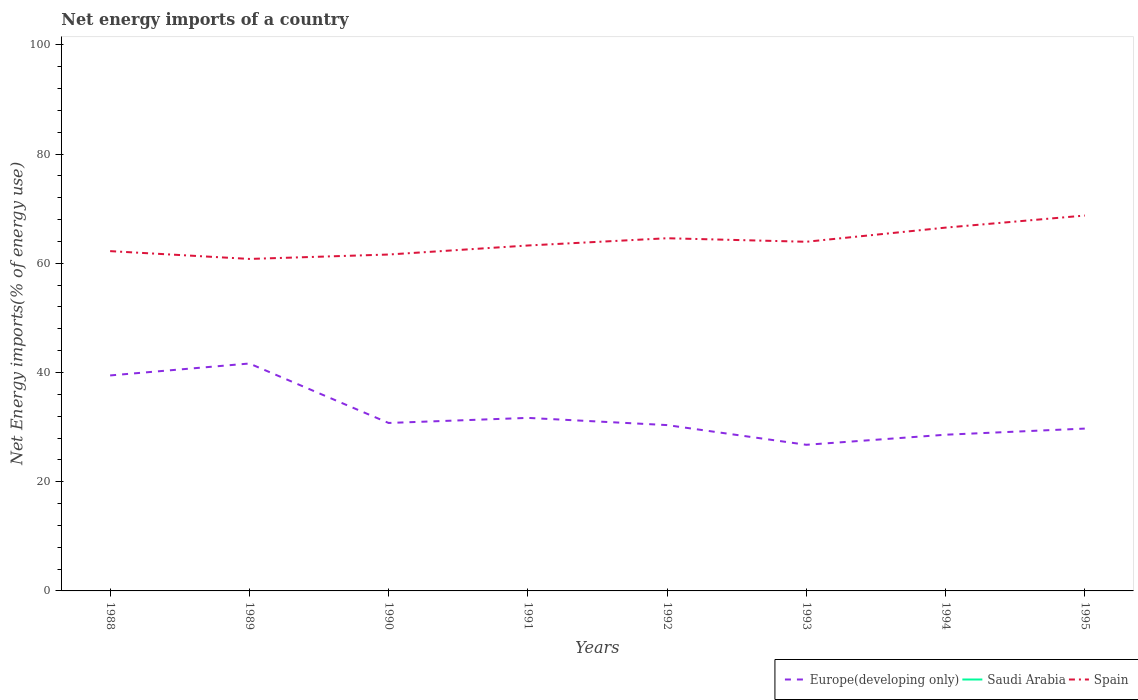How many different coloured lines are there?
Provide a short and direct response. 2. What is the total net energy imports in Spain in the graph?
Offer a terse response. -4.31. What is the difference between the highest and the second highest net energy imports in Europe(developing only)?
Provide a succinct answer. 14.88. Is the net energy imports in Saudi Arabia strictly greater than the net energy imports in Spain over the years?
Your answer should be very brief. Yes. How many years are there in the graph?
Offer a very short reply. 8. What is the difference between two consecutive major ticks on the Y-axis?
Your answer should be compact. 20. Are the values on the major ticks of Y-axis written in scientific E-notation?
Your response must be concise. No. Does the graph contain any zero values?
Make the answer very short. Yes. How are the legend labels stacked?
Make the answer very short. Horizontal. What is the title of the graph?
Your answer should be very brief. Net energy imports of a country. What is the label or title of the Y-axis?
Ensure brevity in your answer.  Net Energy imports(% of energy use). What is the Net Energy imports(% of energy use) in Europe(developing only) in 1988?
Provide a short and direct response. 39.46. What is the Net Energy imports(% of energy use) in Spain in 1988?
Your answer should be compact. 62.22. What is the Net Energy imports(% of energy use) in Europe(developing only) in 1989?
Make the answer very short. 41.64. What is the Net Energy imports(% of energy use) of Saudi Arabia in 1989?
Ensure brevity in your answer.  0. What is the Net Energy imports(% of energy use) in Spain in 1989?
Provide a succinct answer. 60.79. What is the Net Energy imports(% of energy use) in Europe(developing only) in 1990?
Your answer should be very brief. 30.75. What is the Net Energy imports(% of energy use) of Spain in 1990?
Offer a very short reply. 61.6. What is the Net Energy imports(% of energy use) in Europe(developing only) in 1991?
Offer a terse response. 31.68. What is the Net Energy imports(% of energy use) in Spain in 1991?
Ensure brevity in your answer.  63.25. What is the Net Energy imports(% of energy use) in Europe(developing only) in 1992?
Your answer should be compact. 30.36. What is the Net Energy imports(% of energy use) of Spain in 1992?
Offer a terse response. 64.58. What is the Net Energy imports(% of energy use) of Europe(developing only) in 1993?
Make the answer very short. 26.76. What is the Net Energy imports(% of energy use) of Spain in 1993?
Ensure brevity in your answer.  63.93. What is the Net Energy imports(% of energy use) in Europe(developing only) in 1994?
Offer a terse response. 28.6. What is the Net Energy imports(% of energy use) of Saudi Arabia in 1994?
Keep it short and to the point. 0. What is the Net Energy imports(% of energy use) of Spain in 1994?
Your answer should be compact. 66.52. What is the Net Energy imports(% of energy use) of Europe(developing only) in 1995?
Offer a terse response. 29.72. What is the Net Energy imports(% of energy use) of Saudi Arabia in 1995?
Your answer should be compact. 0. What is the Net Energy imports(% of energy use) in Spain in 1995?
Make the answer very short. 68.73. Across all years, what is the maximum Net Energy imports(% of energy use) in Europe(developing only)?
Your answer should be compact. 41.64. Across all years, what is the maximum Net Energy imports(% of energy use) of Spain?
Make the answer very short. 68.73. Across all years, what is the minimum Net Energy imports(% of energy use) of Europe(developing only)?
Ensure brevity in your answer.  26.76. Across all years, what is the minimum Net Energy imports(% of energy use) of Spain?
Provide a short and direct response. 60.79. What is the total Net Energy imports(% of energy use) of Europe(developing only) in the graph?
Ensure brevity in your answer.  258.98. What is the total Net Energy imports(% of energy use) in Spain in the graph?
Offer a very short reply. 511.62. What is the difference between the Net Energy imports(% of energy use) in Europe(developing only) in 1988 and that in 1989?
Your response must be concise. -2.19. What is the difference between the Net Energy imports(% of energy use) in Spain in 1988 and that in 1989?
Your answer should be very brief. 1.43. What is the difference between the Net Energy imports(% of energy use) of Europe(developing only) in 1988 and that in 1990?
Your answer should be very brief. 8.7. What is the difference between the Net Energy imports(% of energy use) in Spain in 1988 and that in 1990?
Offer a terse response. 0.62. What is the difference between the Net Energy imports(% of energy use) of Europe(developing only) in 1988 and that in 1991?
Offer a very short reply. 7.77. What is the difference between the Net Energy imports(% of energy use) of Spain in 1988 and that in 1991?
Offer a terse response. -1.03. What is the difference between the Net Energy imports(% of energy use) of Europe(developing only) in 1988 and that in 1992?
Provide a short and direct response. 9.09. What is the difference between the Net Energy imports(% of energy use) of Spain in 1988 and that in 1992?
Offer a very short reply. -2.36. What is the difference between the Net Energy imports(% of energy use) of Europe(developing only) in 1988 and that in 1993?
Your answer should be compact. 12.7. What is the difference between the Net Energy imports(% of energy use) in Spain in 1988 and that in 1993?
Give a very brief answer. -1.71. What is the difference between the Net Energy imports(% of energy use) of Europe(developing only) in 1988 and that in 1994?
Offer a terse response. 10.85. What is the difference between the Net Energy imports(% of energy use) of Spain in 1988 and that in 1994?
Ensure brevity in your answer.  -4.31. What is the difference between the Net Energy imports(% of energy use) of Europe(developing only) in 1988 and that in 1995?
Your answer should be compact. 9.73. What is the difference between the Net Energy imports(% of energy use) in Spain in 1988 and that in 1995?
Offer a terse response. -6.52. What is the difference between the Net Energy imports(% of energy use) of Europe(developing only) in 1989 and that in 1990?
Offer a very short reply. 10.89. What is the difference between the Net Energy imports(% of energy use) of Spain in 1989 and that in 1990?
Keep it short and to the point. -0.81. What is the difference between the Net Energy imports(% of energy use) of Europe(developing only) in 1989 and that in 1991?
Offer a very short reply. 9.96. What is the difference between the Net Energy imports(% of energy use) in Spain in 1989 and that in 1991?
Provide a succinct answer. -2.46. What is the difference between the Net Energy imports(% of energy use) in Europe(developing only) in 1989 and that in 1992?
Your answer should be very brief. 11.28. What is the difference between the Net Energy imports(% of energy use) in Spain in 1989 and that in 1992?
Your answer should be compact. -3.79. What is the difference between the Net Energy imports(% of energy use) of Europe(developing only) in 1989 and that in 1993?
Provide a succinct answer. 14.88. What is the difference between the Net Energy imports(% of energy use) of Spain in 1989 and that in 1993?
Keep it short and to the point. -3.14. What is the difference between the Net Energy imports(% of energy use) of Europe(developing only) in 1989 and that in 1994?
Keep it short and to the point. 13.04. What is the difference between the Net Energy imports(% of energy use) in Spain in 1989 and that in 1994?
Give a very brief answer. -5.74. What is the difference between the Net Energy imports(% of energy use) in Europe(developing only) in 1989 and that in 1995?
Provide a short and direct response. 11.92. What is the difference between the Net Energy imports(% of energy use) in Spain in 1989 and that in 1995?
Provide a short and direct response. -7.95. What is the difference between the Net Energy imports(% of energy use) of Europe(developing only) in 1990 and that in 1991?
Provide a succinct answer. -0.93. What is the difference between the Net Energy imports(% of energy use) in Spain in 1990 and that in 1991?
Your response must be concise. -1.65. What is the difference between the Net Energy imports(% of energy use) of Europe(developing only) in 1990 and that in 1992?
Make the answer very short. 0.39. What is the difference between the Net Energy imports(% of energy use) of Spain in 1990 and that in 1992?
Offer a terse response. -2.98. What is the difference between the Net Energy imports(% of energy use) in Europe(developing only) in 1990 and that in 1993?
Provide a succinct answer. 4. What is the difference between the Net Energy imports(% of energy use) in Spain in 1990 and that in 1993?
Give a very brief answer. -2.33. What is the difference between the Net Energy imports(% of energy use) of Europe(developing only) in 1990 and that in 1994?
Your response must be concise. 2.15. What is the difference between the Net Energy imports(% of energy use) of Spain in 1990 and that in 1994?
Make the answer very short. -4.93. What is the difference between the Net Energy imports(% of energy use) in Europe(developing only) in 1990 and that in 1995?
Offer a terse response. 1.03. What is the difference between the Net Energy imports(% of energy use) in Spain in 1990 and that in 1995?
Make the answer very short. -7.14. What is the difference between the Net Energy imports(% of energy use) of Europe(developing only) in 1991 and that in 1992?
Keep it short and to the point. 1.32. What is the difference between the Net Energy imports(% of energy use) in Spain in 1991 and that in 1992?
Keep it short and to the point. -1.33. What is the difference between the Net Energy imports(% of energy use) of Europe(developing only) in 1991 and that in 1993?
Your answer should be very brief. 4.93. What is the difference between the Net Energy imports(% of energy use) in Spain in 1991 and that in 1993?
Your answer should be compact. -0.68. What is the difference between the Net Energy imports(% of energy use) of Europe(developing only) in 1991 and that in 1994?
Provide a short and direct response. 3.08. What is the difference between the Net Energy imports(% of energy use) in Spain in 1991 and that in 1994?
Offer a very short reply. -3.27. What is the difference between the Net Energy imports(% of energy use) of Europe(developing only) in 1991 and that in 1995?
Make the answer very short. 1.96. What is the difference between the Net Energy imports(% of energy use) of Spain in 1991 and that in 1995?
Your answer should be very brief. -5.48. What is the difference between the Net Energy imports(% of energy use) in Europe(developing only) in 1992 and that in 1993?
Give a very brief answer. 3.61. What is the difference between the Net Energy imports(% of energy use) in Spain in 1992 and that in 1993?
Provide a succinct answer. 0.65. What is the difference between the Net Energy imports(% of energy use) of Europe(developing only) in 1992 and that in 1994?
Your answer should be compact. 1.76. What is the difference between the Net Energy imports(% of energy use) of Spain in 1992 and that in 1994?
Your response must be concise. -1.95. What is the difference between the Net Energy imports(% of energy use) in Europe(developing only) in 1992 and that in 1995?
Your response must be concise. 0.64. What is the difference between the Net Energy imports(% of energy use) of Spain in 1992 and that in 1995?
Ensure brevity in your answer.  -4.16. What is the difference between the Net Energy imports(% of energy use) of Europe(developing only) in 1993 and that in 1994?
Offer a terse response. -1.84. What is the difference between the Net Energy imports(% of energy use) of Spain in 1993 and that in 1994?
Provide a succinct answer. -2.59. What is the difference between the Net Energy imports(% of energy use) in Europe(developing only) in 1993 and that in 1995?
Give a very brief answer. -2.97. What is the difference between the Net Energy imports(% of energy use) of Spain in 1993 and that in 1995?
Provide a succinct answer. -4.8. What is the difference between the Net Energy imports(% of energy use) of Europe(developing only) in 1994 and that in 1995?
Keep it short and to the point. -1.12. What is the difference between the Net Energy imports(% of energy use) in Spain in 1994 and that in 1995?
Your answer should be compact. -2.21. What is the difference between the Net Energy imports(% of energy use) of Europe(developing only) in 1988 and the Net Energy imports(% of energy use) of Spain in 1989?
Make the answer very short. -21.33. What is the difference between the Net Energy imports(% of energy use) of Europe(developing only) in 1988 and the Net Energy imports(% of energy use) of Spain in 1990?
Make the answer very short. -22.14. What is the difference between the Net Energy imports(% of energy use) in Europe(developing only) in 1988 and the Net Energy imports(% of energy use) in Spain in 1991?
Your response must be concise. -23.79. What is the difference between the Net Energy imports(% of energy use) of Europe(developing only) in 1988 and the Net Energy imports(% of energy use) of Spain in 1992?
Make the answer very short. -25.12. What is the difference between the Net Energy imports(% of energy use) of Europe(developing only) in 1988 and the Net Energy imports(% of energy use) of Spain in 1993?
Your answer should be compact. -24.48. What is the difference between the Net Energy imports(% of energy use) in Europe(developing only) in 1988 and the Net Energy imports(% of energy use) in Spain in 1994?
Give a very brief answer. -27.07. What is the difference between the Net Energy imports(% of energy use) of Europe(developing only) in 1988 and the Net Energy imports(% of energy use) of Spain in 1995?
Provide a short and direct response. -29.28. What is the difference between the Net Energy imports(% of energy use) of Europe(developing only) in 1989 and the Net Energy imports(% of energy use) of Spain in 1990?
Ensure brevity in your answer.  -19.95. What is the difference between the Net Energy imports(% of energy use) of Europe(developing only) in 1989 and the Net Energy imports(% of energy use) of Spain in 1991?
Give a very brief answer. -21.61. What is the difference between the Net Energy imports(% of energy use) in Europe(developing only) in 1989 and the Net Energy imports(% of energy use) in Spain in 1992?
Your response must be concise. -22.94. What is the difference between the Net Energy imports(% of energy use) in Europe(developing only) in 1989 and the Net Energy imports(% of energy use) in Spain in 1993?
Provide a succinct answer. -22.29. What is the difference between the Net Energy imports(% of energy use) in Europe(developing only) in 1989 and the Net Energy imports(% of energy use) in Spain in 1994?
Your response must be concise. -24.88. What is the difference between the Net Energy imports(% of energy use) of Europe(developing only) in 1989 and the Net Energy imports(% of energy use) of Spain in 1995?
Ensure brevity in your answer.  -27.09. What is the difference between the Net Energy imports(% of energy use) of Europe(developing only) in 1990 and the Net Energy imports(% of energy use) of Spain in 1991?
Keep it short and to the point. -32.49. What is the difference between the Net Energy imports(% of energy use) in Europe(developing only) in 1990 and the Net Energy imports(% of energy use) in Spain in 1992?
Keep it short and to the point. -33.82. What is the difference between the Net Energy imports(% of energy use) of Europe(developing only) in 1990 and the Net Energy imports(% of energy use) of Spain in 1993?
Keep it short and to the point. -33.18. What is the difference between the Net Energy imports(% of energy use) of Europe(developing only) in 1990 and the Net Energy imports(% of energy use) of Spain in 1994?
Your answer should be compact. -35.77. What is the difference between the Net Energy imports(% of energy use) in Europe(developing only) in 1990 and the Net Energy imports(% of energy use) in Spain in 1995?
Offer a very short reply. -37.98. What is the difference between the Net Energy imports(% of energy use) in Europe(developing only) in 1991 and the Net Energy imports(% of energy use) in Spain in 1992?
Give a very brief answer. -32.89. What is the difference between the Net Energy imports(% of energy use) in Europe(developing only) in 1991 and the Net Energy imports(% of energy use) in Spain in 1993?
Provide a short and direct response. -32.25. What is the difference between the Net Energy imports(% of energy use) of Europe(developing only) in 1991 and the Net Energy imports(% of energy use) of Spain in 1994?
Make the answer very short. -34.84. What is the difference between the Net Energy imports(% of energy use) in Europe(developing only) in 1991 and the Net Energy imports(% of energy use) in Spain in 1995?
Make the answer very short. -37.05. What is the difference between the Net Energy imports(% of energy use) of Europe(developing only) in 1992 and the Net Energy imports(% of energy use) of Spain in 1993?
Provide a short and direct response. -33.57. What is the difference between the Net Energy imports(% of energy use) of Europe(developing only) in 1992 and the Net Energy imports(% of energy use) of Spain in 1994?
Keep it short and to the point. -36.16. What is the difference between the Net Energy imports(% of energy use) in Europe(developing only) in 1992 and the Net Energy imports(% of energy use) in Spain in 1995?
Offer a very short reply. -38.37. What is the difference between the Net Energy imports(% of energy use) of Europe(developing only) in 1993 and the Net Energy imports(% of energy use) of Spain in 1994?
Offer a terse response. -39.77. What is the difference between the Net Energy imports(% of energy use) of Europe(developing only) in 1993 and the Net Energy imports(% of energy use) of Spain in 1995?
Give a very brief answer. -41.98. What is the difference between the Net Energy imports(% of energy use) of Europe(developing only) in 1994 and the Net Energy imports(% of energy use) of Spain in 1995?
Provide a succinct answer. -40.13. What is the average Net Energy imports(% of energy use) in Europe(developing only) per year?
Offer a terse response. 32.37. What is the average Net Energy imports(% of energy use) of Spain per year?
Ensure brevity in your answer.  63.95. In the year 1988, what is the difference between the Net Energy imports(% of energy use) of Europe(developing only) and Net Energy imports(% of energy use) of Spain?
Provide a succinct answer. -22.76. In the year 1989, what is the difference between the Net Energy imports(% of energy use) in Europe(developing only) and Net Energy imports(% of energy use) in Spain?
Offer a terse response. -19.15. In the year 1990, what is the difference between the Net Energy imports(% of energy use) of Europe(developing only) and Net Energy imports(% of energy use) of Spain?
Ensure brevity in your answer.  -30.84. In the year 1991, what is the difference between the Net Energy imports(% of energy use) of Europe(developing only) and Net Energy imports(% of energy use) of Spain?
Ensure brevity in your answer.  -31.57. In the year 1992, what is the difference between the Net Energy imports(% of energy use) of Europe(developing only) and Net Energy imports(% of energy use) of Spain?
Your answer should be very brief. -34.21. In the year 1993, what is the difference between the Net Energy imports(% of energy use) of Europe(developing only) and Net Energy imports(% of energy use) of Spain?
Provide a short and direct response. -37.17. In the year 1994, what is the difference between the Net Energy imports(% of energy use) of Europe(developing only) and Net Energy imports(% of energy use) of Spain?
Your answer should be very brief. -37.92. In the year 1995, what is the difference between the Net Energy imports(% of energy use) in Europe(developing only) and Net Energy imports(% of energy use) in Spain?
Give a very brief answer. -39.01. What is the ratio of the Net Energy imports(% of energy use) in Europe(developing only) in 1988 to that in 1989?
Provide a succinct answer. 0.95. What is the ratio of the Net Energy imports(% of energy use) of Spain in 1988 to that in 1989?
Provide a succinct answer. 1.02. What is the ratio of the Net Energy imports(% of energy use) of Europe(developing only) in 1988 to that in 1990?
Your answer should be compact. 1.28. What is the ratio of the Net Energy imports(% of energy use) of Europe(developing only) in 1988 to that in 1991?
Provide a short and direct response. 1.25. What is the ratio of the Net Energy imports(% of energy use) in Spain in 1988 to that in 1991?
Offer a very short reply. 0.98. What is the ratio of the Net Energy imports(% of energy use) in Europe(developing only) in 1988 to that in 1992?
Your answer should be compact. 1.3. What is the ratio of the Net Energy imports(% of energy use) of Spain in 1988 to that in 1992?
Make the answer very short. 0.96. What is the ratio of the Net Energy imports(% of energy use) in Europe(developing only) in 1988 to that in 1993?
Ensure brevity in your answer.  1.47. What is the ratio of the Net Energy imports(% of energy use) in Spain in 1988 to that in 1993?
Offer a terse response. 0.97. What is the ratio of the Net Energy imports(% of energy use) of Europe(developing only) in 1988 to that in 1994?
Provide a succinct answer. 1.38. What is the ratio of the Net Energy imports(% of energy use) of Spain in 1988 to that in 1994?
Make the answer very short. 0.94. What is the ratio of the Net Energy imports(% of energy use) in Europe(developing only) in 1988 to that in 1995?
Keep it short and to the point. 1.33. What is the ratio of the Net Energy imports(% of energy use) in Spain in 1988 to that in 1995?
Your response must be concise. 0.91. What is the ratio of the Net Energy imports(% of energy use) in Europe(developing only) in 1989 to that in 1990?
Give a very brief answer. 1.35. What is the ratio of the Net Energy imports(% of energy use) in Spain in 1989 to that in 1990?
Your response must be concise. 0.99. What is the ratio of the Net Energy imports(% of energy use) of Europe(developing only) in 1989 to that in 1991?
Offer a terse response. 1.31. What is the ratio of the Net Energy imports(% of energy use) in Spain in 1989 to that in 1991?
Provide a short and direct response. 0.96. What is the ratio of the Net Energy imports(% of energy use) in Europe(developing only) in 1989 to that in 1992?
Ensure brevity in your answer.  1.37. What is the ratio of the Net Energy imports(% of energy use) of Spain in 1989 to that in 1992?
Your answer should be compact. 0.94. What is the ratio of the Net Energy imports(% of energy use) of Europe(developing only) in 1989 to that in 1993?
Provide a short and direct response. 1.56. What is the ratio of the Net Energy imports(% of energy use) in Spain in 1989 to that in 1993?
Provide a succinct answer. 0.95. What is the ratio of the Net Energy imports(% of energy use) in Europe(developing only) in 1989 to that in 1994?
Your response must be concise. 1.46. What is the ratio of the Net Energy imports(% of energy use) of Spain in 1989 to that in 1994?
Make the answer very short. 0.91. What is the ratio of the Net Energy imports(% of energy use) in Europe(developing only) in 1989 to that in 1995?
Provide a short and direct response. 1.4. What is the ratio of the Net Energy imports(% of energy use) in Spain in 1989 to that in 1995?
Offer a very short reply. 0.88. What is the ratio of the Net Energy imports(% of energy use) in Europe(developing only) in 1990 to that in 1991?
Give a very brief answer. 0.97. What is the ratio of the Net Energy imports(% of energy use) of Spain in 1990 to that in 1991?
Ensure brevity in your answer.  0.97. What is the ratio of the Net Energy imports(% of energy use) of Europe(developing only) in 1990 to that in 1992?
Ensure brevity in your answer.  1.01. What is the ratio of the Net Energy imports(% of energy use) in Spain in 1990 to that in 1992?
Offer a very short reply. 0.95. What is the ratio of the Net Energy imports(% of energy use) in Europe(developing only) in 1990 to that in 1993?
Keep it short and to the point. 1.15. What is the ratio of the Net Energy imports(% of energy use) of Spain in 1990 to that in 1993?
Give a very brief answer. 0.96. What is the ratio of the Net Energy imports(% of energy use) in Europe(developing only) in 1990 to that in 1994?
Offer a terse response. 1.08. What is the ratio of the Net Energy imports(% of energy use) of Spain in 1990 to that in 1994?
Keep it short and to the point. 0.93. What is the ratio of the Net Energy imports(% of energy use) of Europe(developing only) in 1990 to that in 1995?
Your response must be concise. 1.03. What is the ratio of the Net Energy imports(% of energy use) of Spain in 1990 to that in 1995?
Provide a short and direct response. 0.9. What is the ratio of the Net Energy imports(% of energy use) of Europe(developing only) in 1991 to that in 1992?
Offer a terse response. 1.04. What is the ratio of the Net Energy imports(% of energy use) of Spain in 1991 to that in 1992?
Your answer should be compact. 0.98. What is the ratio of the Net Energy imports(% of energy use) of Europe(developing only) in 1991 to that in 1993?
Your response must be concise. 1.18. What is the ratio of the Net Energy imports(% of energy use) in Spain in 1991 to that in 1993?
Offer a very short reply. 0.99. What is the ratio of the Net Energy imports(% of energy use) of Europe(developing only) in 1991 to that in 1994?
Your answer should be compact. 1.11. What is the ratio of the Net Energy imports(% of energy use) in Spain in 1991 to that in 1994?
Make the answer very short. 0.95. What is the ratio of the Net Energy imports(% of energy use) of Europe(developing only) in 1991 to that in 1995?
Provide a succinct answer. 1.07. What is the ratio of the Net Energy imports(% of energy use) in Spain in 1991 to that in 1995?
Your answer should be very brief. 0.92. What is the ratio of the Net Energy imports(% of energy use) of Europe(developing only) in 1992 to that in 1993?
Offer a terse response. 1.13. What is the ratio of the Net Energy imports(% of energy use) in Spain in 1992 to that in 1993?
Ensure brevity in your answer.  1.01. What is the ratio of the Net Energy imports(% of energy use) of Europe(developing only) in 1992 to that in 1994?
Ensure brevity in your answer.  1.06. What is the ratio of the Net Energy imports(% of energy use) of Spain in 1992 to that in 1994?
Your answer should be very brief. 0.97. What is the ratio of the Net Energy imports(% of energy use) of Europe(developing only) in 1992 to that in 1995?
Your answer should be compact. 1.02. What is the ratio of the Net Energy imports(% of energy use) of Spain in 1992 to that in 1995?
Your response must be concise. 0.94. What is the ratio of the Net Energy imports(% of energy use) in Europe(developing only) in 1993 to that in 1994?
Offer a very short reply. 0.94. What is the ratio of the Net Energy imports(% of energy use) in Spain in 1993 to that in 1994?
Your answer should be compact. 0.96. What is the ratio of the Net Energy imports(% of energy use) in Europe(developing only) in 1993 to that in 1995?
Keep it short and to the point. 0.9. What is the ratio of the Net Energy imports(% of energy use) in Spain in 1993 to that in 1995?
Your answer should be very brief. 0.93. What is the ratio of the Net Energy imports(% of energy use) of Europe(developing only) in 1994 to that in 1995?
Provide a short and direct response. 0.96. What is the ratio of the Net Energy imports(% of energy use) of Spain in 1994 to that in 1995?
Ensure brevity in your answer.  0.97. What is the difference between the highest and the second highest Net Energy imports(% of energy use) in Europe(developing only)?
Make the answer very short. 2.19. What is the difference between the highest and the second highest Net Energy imports(% of energy use) in Spain?
Keep it short and to the point. 2.21. What is the difference between the highest and the lowest Net Energy imports(% of energy use) in Europe(developing only)?
Offer a very short reply. 14.88. What is the difference between the highest and the lowest Net Energy imports(% of energy use) of Spain?
Offer a terse response. 7.95. 